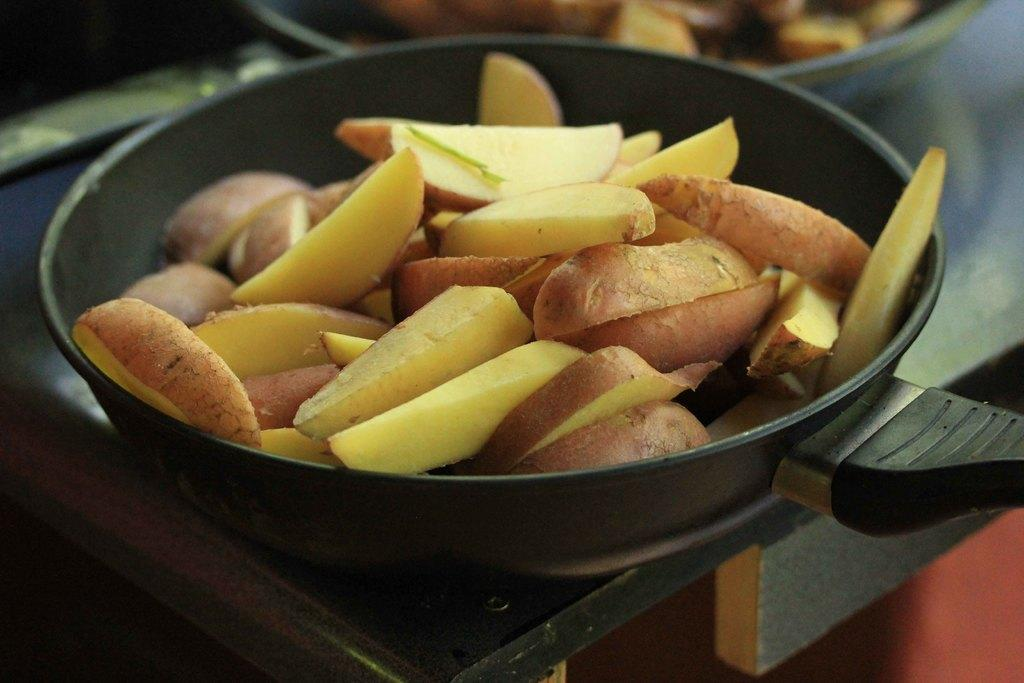What type of food can be seen in the pan in the image? There are fruits in the pan in the image. Where is the pan located? The pan is placed on a table. What type of glue is being used to hold the kitten's bone together in the image? There is no kitten, bone, or glue present in the image. 